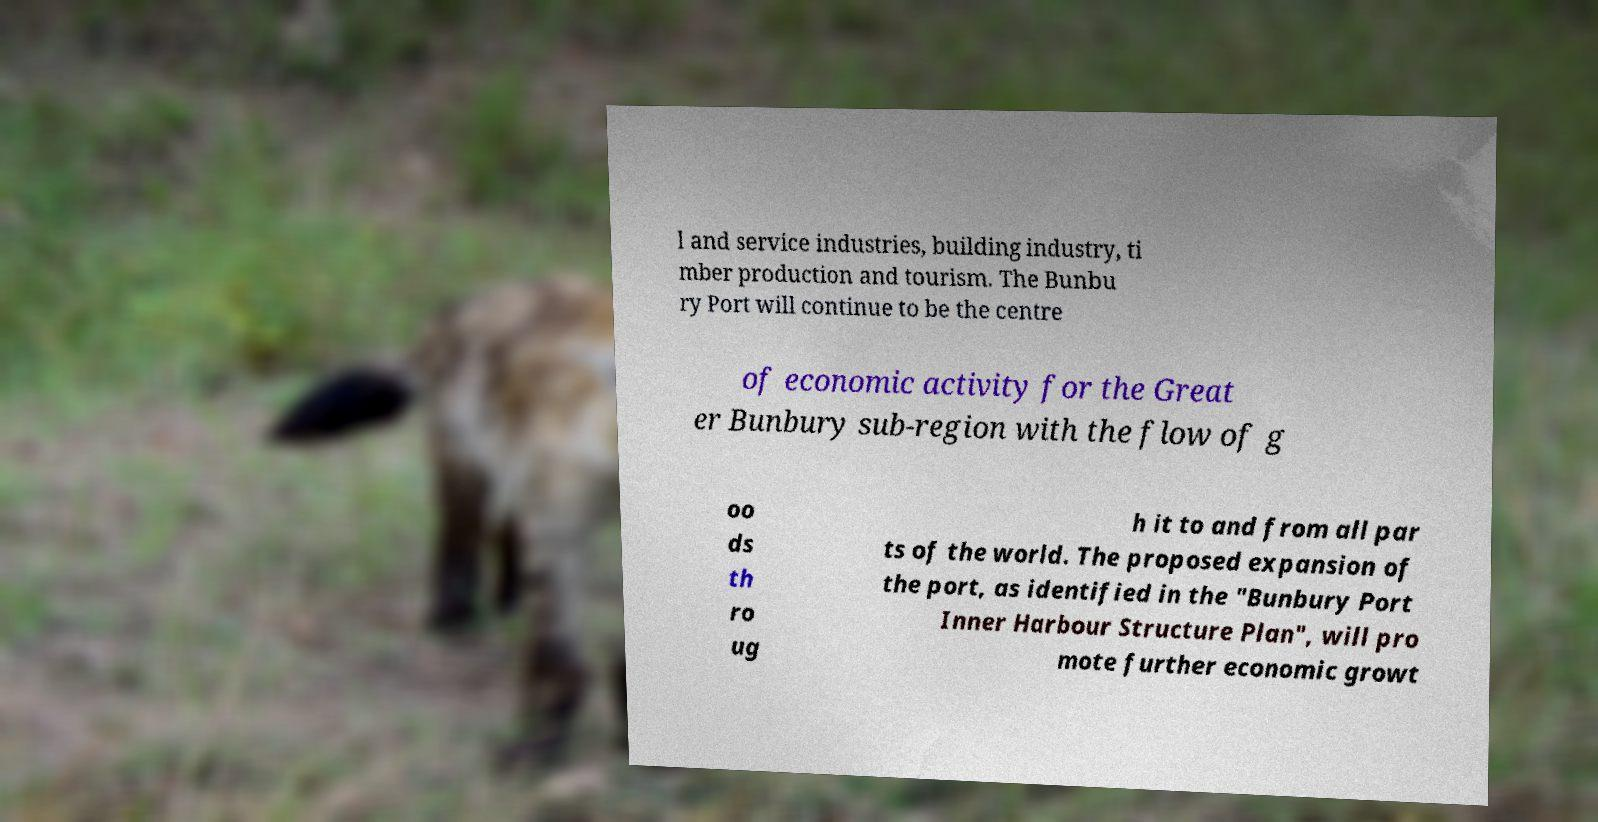I need the written content from this picture converted into text. Can you do that? l and service industries, building industry, ti mber production and tourism. The Bunbu ry Port will continue to be the centre of economic activity for the Great er Bunbury sub-region with the flow of g oo ds th ro ug h it to and from all par ts of the world. The proposed expansion of the port, as identified in the "Bunbury Port Inner Harbour Structure Plan", will pro mote further economic growt 